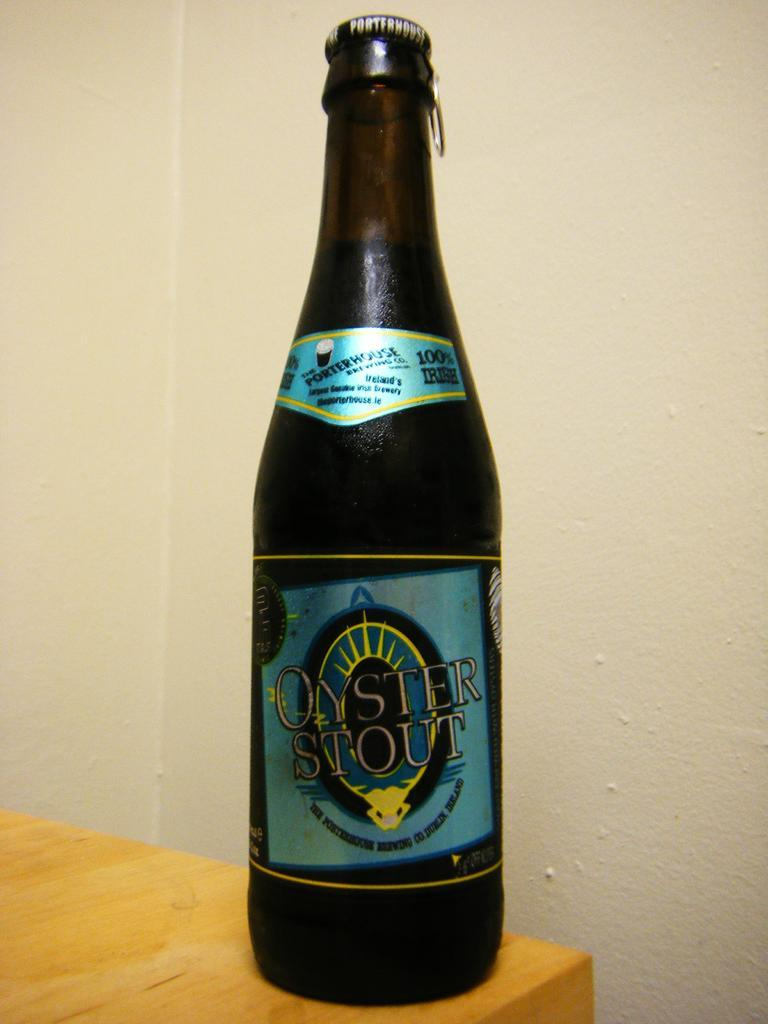<image>
Give a short and clear explanation of the subsequent image. A bottle of Oyster stout has a blue label and sits on a wooden table. 